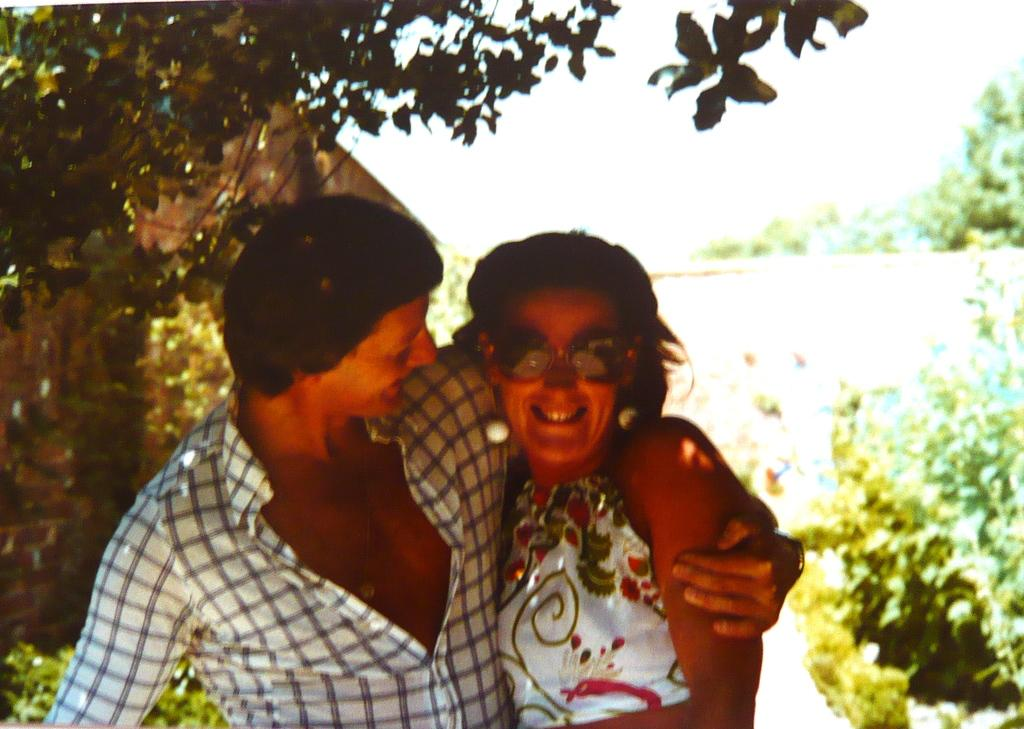Who is present in the image? There is a couple in the image. What is the couple doing in the image? The couple is smiling. What can be seen in the background of the image? There is a house with red bricks, trees, plants, and the sky visible in the background. What type of chess piece is on the table in the image? There is no chess piece or table present in the image. What type of cannon is visible in the background of the image? There is no cannon present in the image. 